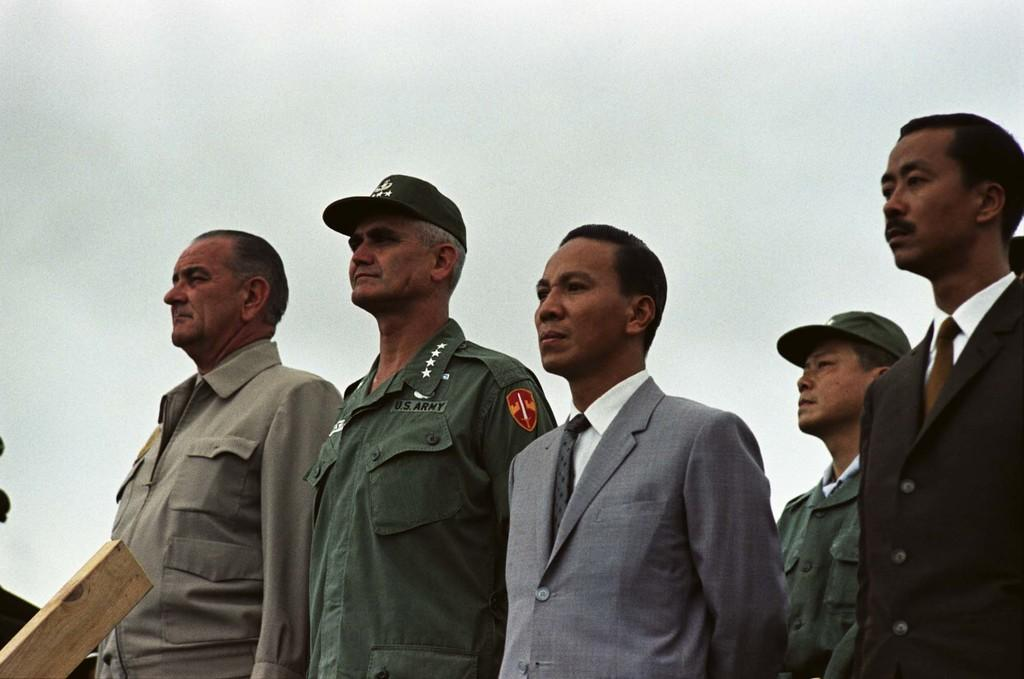What is happening in the image? There is a group of people standing in the image. Can you describe any objects or structures in the image? There is a wooden pole in the bottom left corner of the image. What can be seen in the background of the image? The sky is visible in the background of the image. Are there any cacti visible in the image? No, there are no cacti present in the image. 